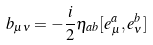<formula> <loc_0><loc_0><loc_500><loc_500>b _ { \mu \nu } = - \frac { i } { 2 } \eta _ { a b } [ e ^ { a } _ { \mu } , e ^ { b } _ { \nu } ]</formula> 